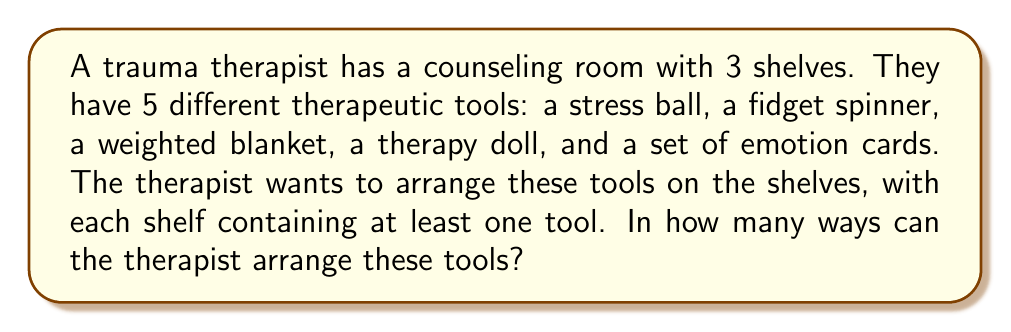Give your solution to this math problem. To solve this problem, we'll use the concept of Stirling numbers of the second kind and the multiplication principle.

1) First, we need to consider the number of ways to distribute 5 distinct objects (therapeutic tools) into 3 non-empty groups (shelves). This is given by the Stirling number of the second kind, denoted as $\stirling{5}{3}$.

2) The formula for this Stirling number is:

   $$\stirling{5}{3} = \frac{1}{3!}\sum_{i=0}^3 (-1)^i \binom{3}{i}(3-i)^5$$

3) Expanding this:
   
   $$\stirling{5}{3} = \frac{1}{6}[(3^5) - 3(2^5) + 3(1^5) - 0]$$
   $$= \frac{1}{6}[243 - 96 + 3]$$
   $$= \frac{1}{6}[150] = 25$$

4) This gives us the number of ways to distribute the tools into 3 non-empty shelves. However, for each of these distributions, we need to consider the number of ways to arrange the tools within each shelf.

5) For any given distribution, we can arrange the tools on each shelf in $3!$ ways, as there are 3 distinct positions (shelves).

6) Therefore, by the multiplication principle, the total number of arrangements is:

   $$25 \times 3! = 25 \times 6 = 150$$

Thus, there are 150 possible arrangements of the therapeutic tools in the counseling room.
Answer: 150 arrangements 